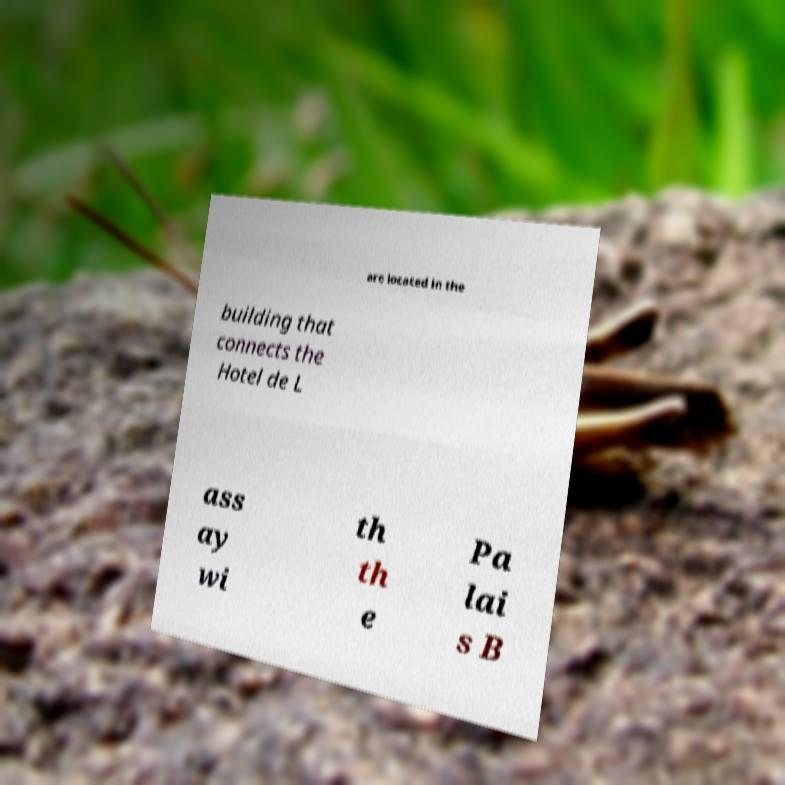Please identify and transcribe the text found in this image. are located in the building that connects the Hotel de L ass ay wi th th e Pa lai s B 